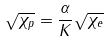<formula> <loc_0><loc_0><loc_500><loc_500>\sqrt { \chi _ { p } } = \frac { \alpha } { K } \sqrt { \chi _ { e } }</formula> 